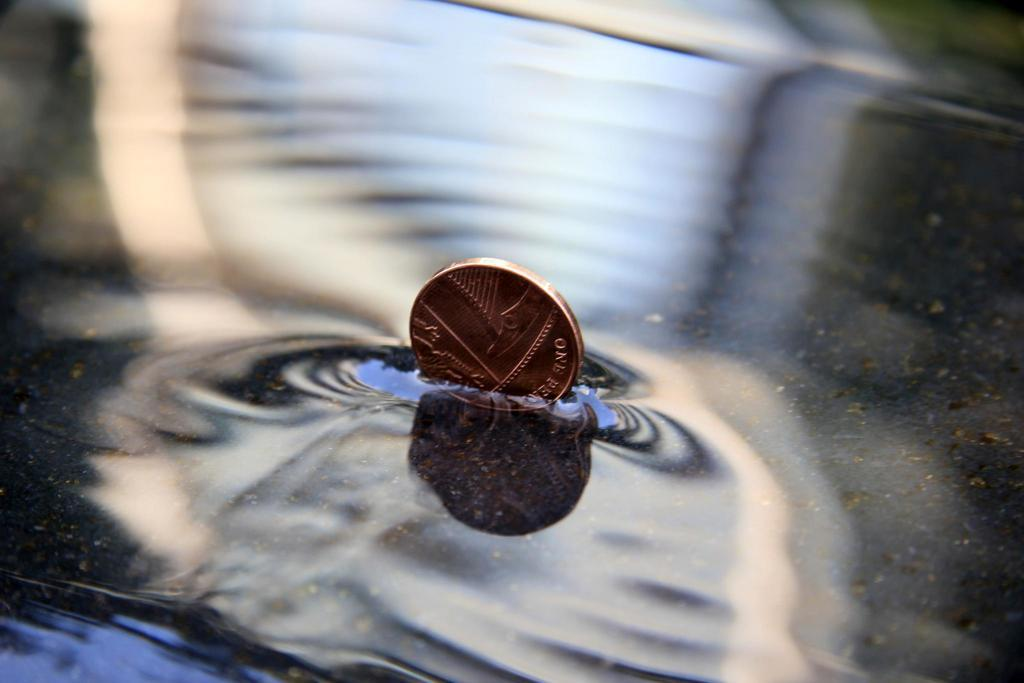What object is in the water in the image? There is a coin in the water. How much of the coin is submerged in the water? Half of the coin is submerged in the water. What type of news is being reported by the bat in the image? There is no bat or news present in the image; it only features a coin in the water. 